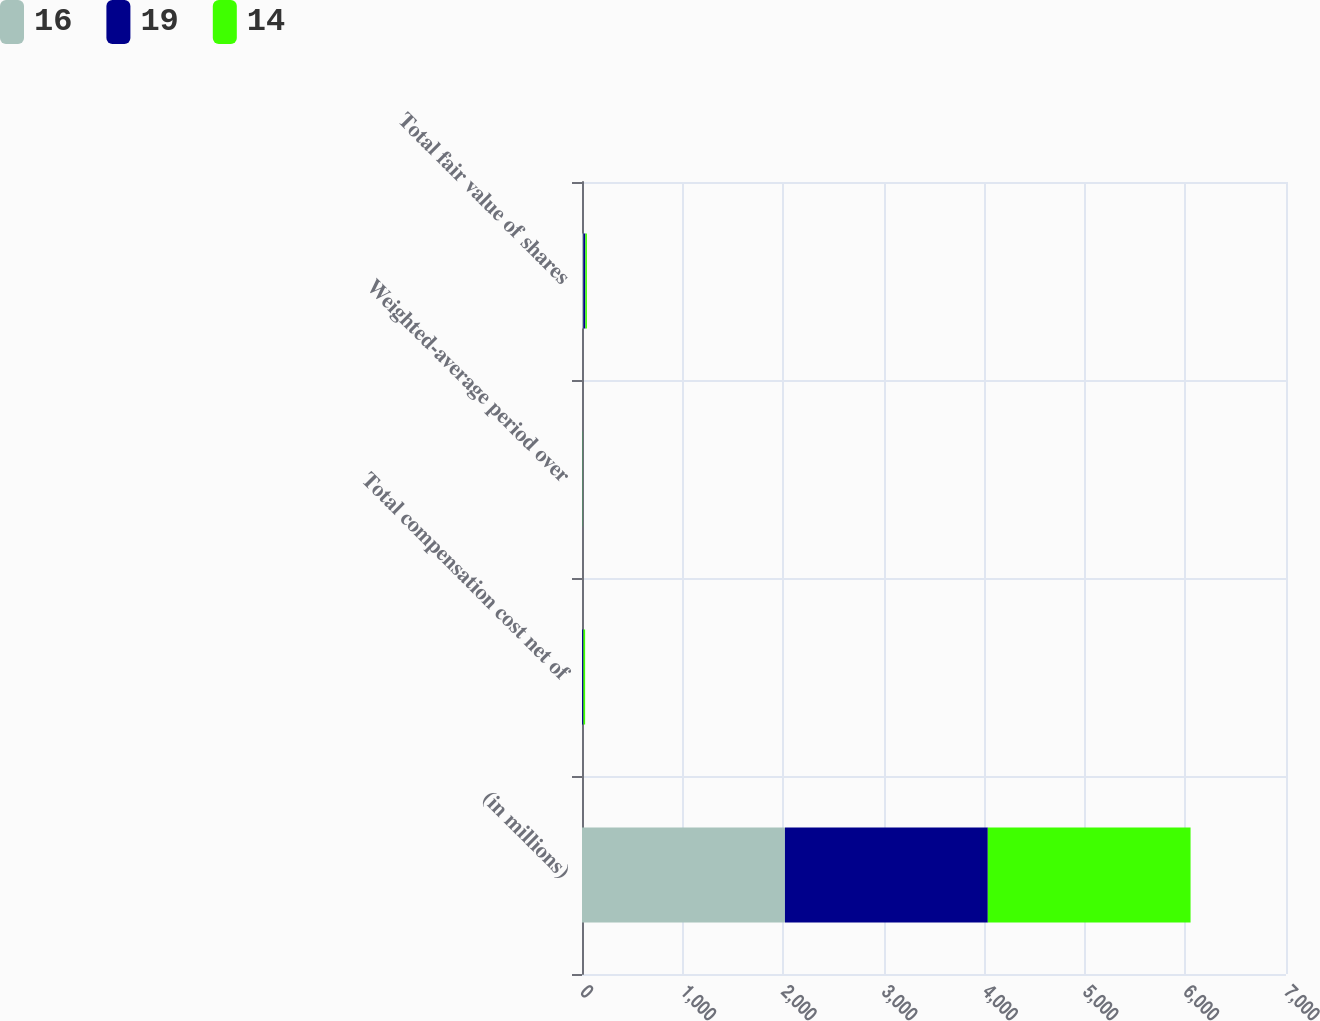Convert chart. <chart><loc_0><loc_0><loc_500><loc_500><stacked_bar_chart><ecel><fcel>(in millions)<fcel>Total compensation cost net of<fcel>Weighted-average period over<fcel>Total fair value of shares<nl><fcel>16<fcel>2018<fcel>1<fcel>2<fcel>14<nl><fcel>19<fcel>2017<fcel>13<fcel>2<fcel>19<nl><fcel>14<fcel>2016<fcel>17<fcel>2<fcel>16<nl></chart> 